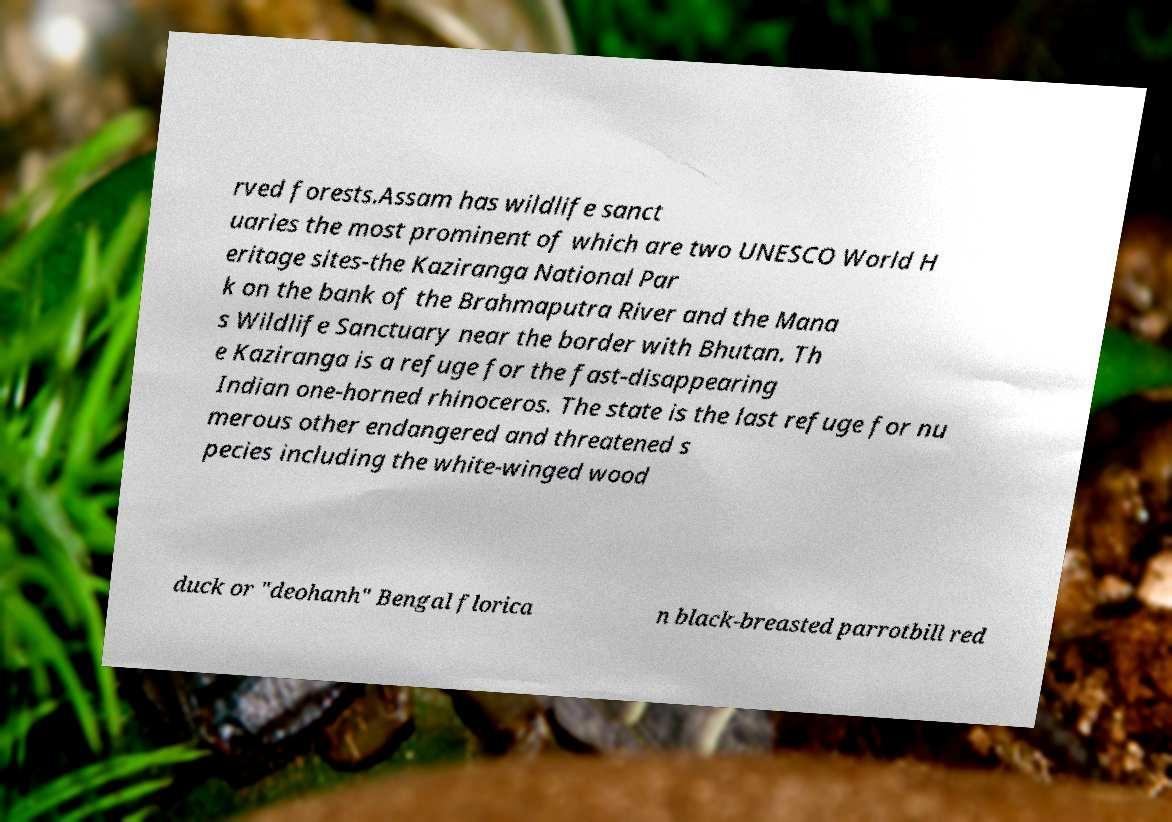What messages or text are displayed in this image? I need them in a readable, typed format. rved forests.Assam has wildlife sanct uaries the most prominent of which are two UNESCO World H eritage sites-the Kaziranga National Par k on the bank of the Brahmaputra River and the Mana s Wildlife Sanctuary near the border with Bhutan. Th e Kaziranga is a refuge for the fast-disappearing Indian one-horned rhinoceros. The state is the last refuge for nu merous other endangered and threatened s pecies including the white-winged wood duck or "deohanh" Bengal florica n black-breasted parrotbill red 